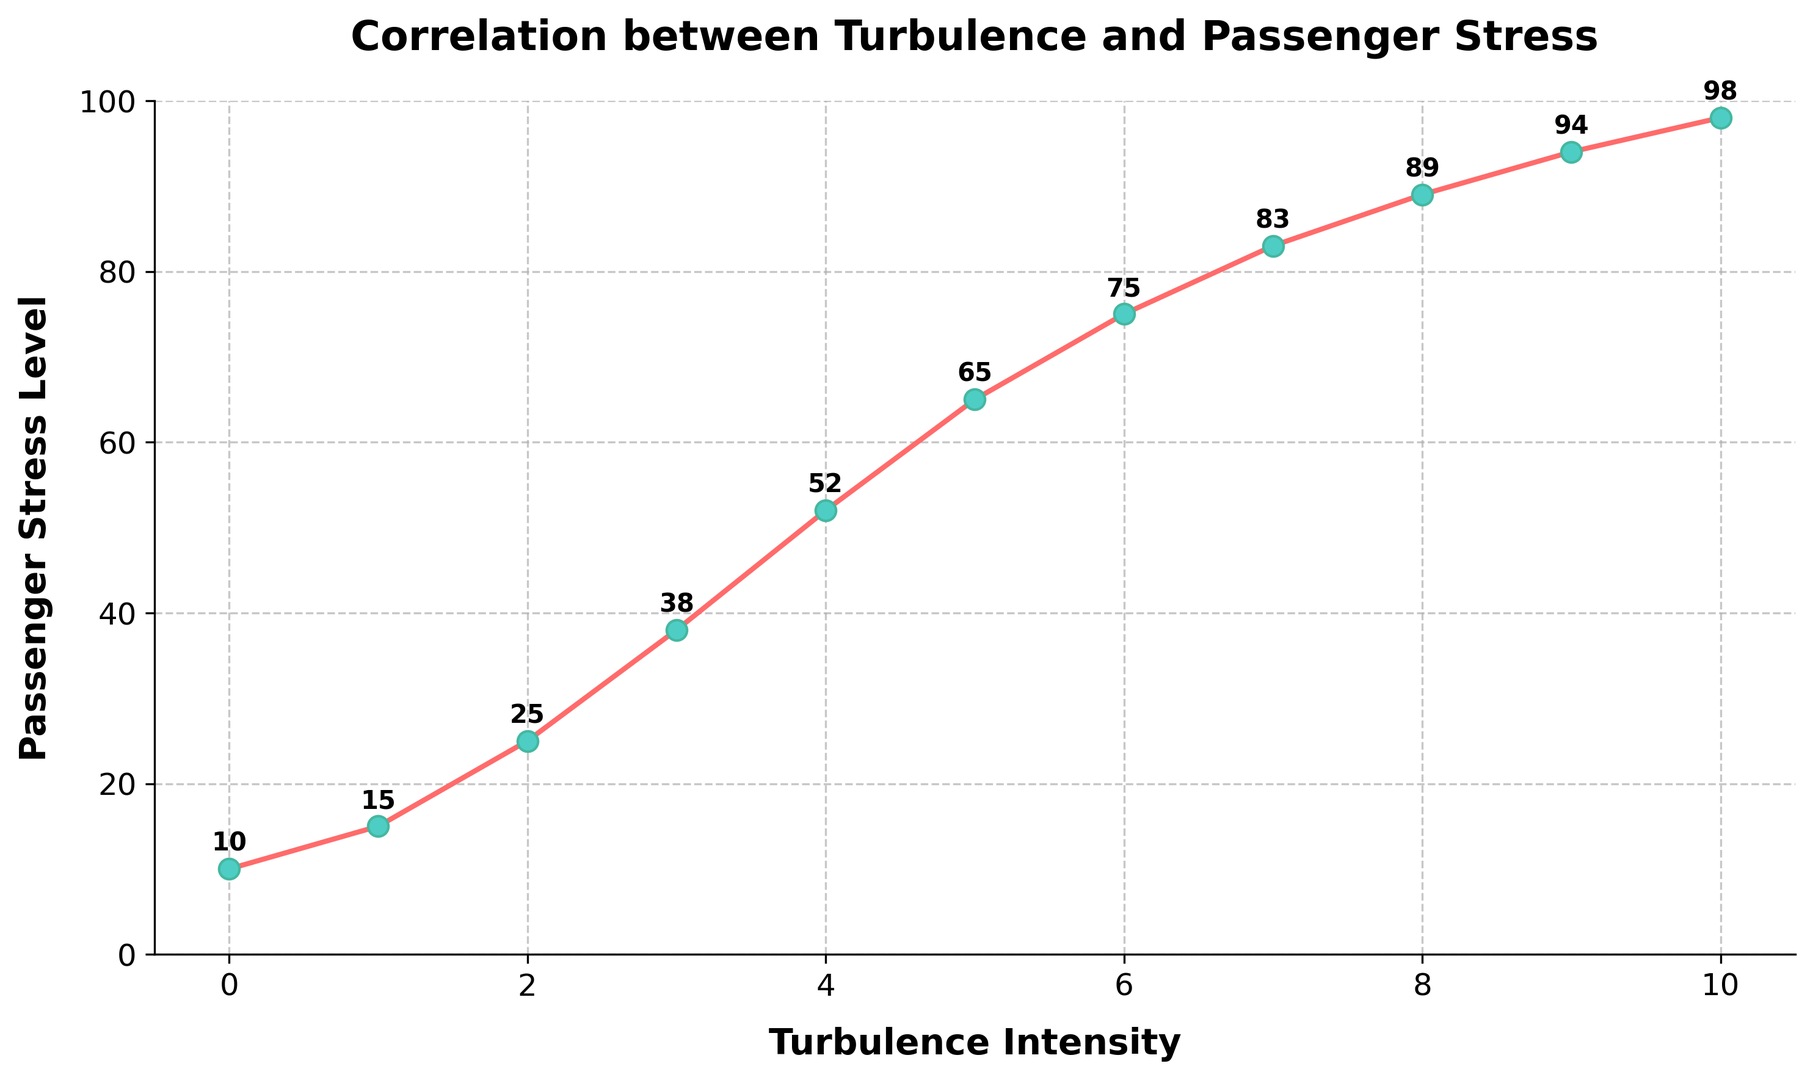What is the stress level for a turbulence intensity of 5? Look at the data point where the x-axis (Turbulence Intensity) is 5, then note the corresponding value on the y-axis (Passenger Stress Level).
Answer: 65 Which turbulence intensity value corresponds to the highest passenger stress level? Identify the highest point on the y-axis (Passenger Stress Level) and then find the corresponding value on the x-axis (Turbulence Intensity).
Answer: 10 What is the difference in passenger stress levels between turbulence intensities of 2 and 6? Find the stress levels corresponding to turbulence intensities of 2 and 6, which are 25 and 75, respectively. Subtract the former from the latter (75 - 25).
Answer: 50 Is the passenger stress level higher at a turbulence intensity of 4 or 7? Compare the stress levels at turbulence intensities of 4 and 7. The stress levels are 52 and 83, respectively, so 83 is higher.
Answer: 7 What is the average passenger stress level for turbulence intensities from 0 to 2 inclusive? Take the stress levels for turbulence intensities 0, 1, and 2, which are 10, 15, and 25. Compute the average: (10 + 15 + 25) / 3.
Answer: 16.67 How does the passenger stress level change as the turbulence intensity increases from 8 to 9? Look at the stress levels for turbulence intensities 8 and 9, which are 89 and 94, respectively. The change is 94 - 89.
Answer: 5 Which interval of turbulence intensity (3 to 6 or 7 to 10) shows a larger increase in passenger stress levels? Calculate the increases for both intervals. For 3 to 6: 75 - 38 = 37. For 7 to 10: 98 - 83 = 15. Compare the two changes.
Answer: 3 to 6 At which turbulence intensity do we see the steepest increase in passenger stress level? Identify where the difference between consecutive data points in the y-axis (stress levels) is the greatest. The steepest increase is from 2 to 3, where the stress level increases from 25 to 38 (a difference of 13).
Answer: 3 What is the median passenger stress level considering all the turbulence intensities? List all the stress level values (10, 15, 25, 38, 52, 65, 75, 83, 89, 94, 98) and find the middle value, which is 65 for an odd number of values.
Answer: 65 